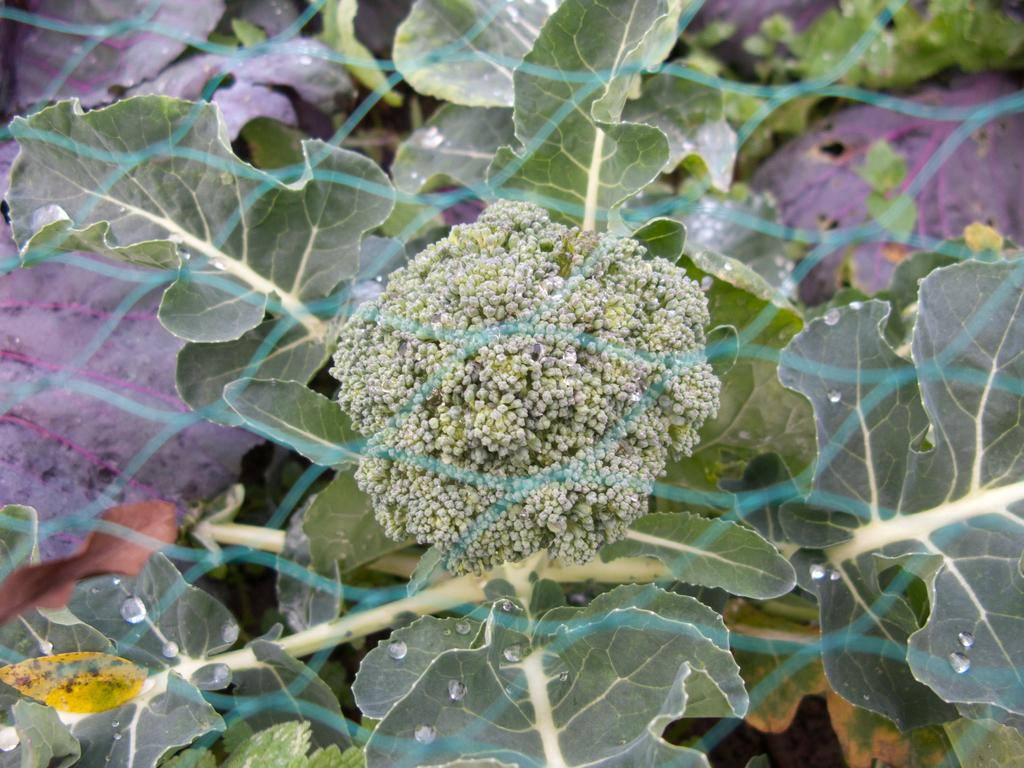What is located in the front of the image? There is a plant in the front of the image. What part of the plant is visible in the image? The plant has leaves on it. What is your opinion on the top doll in the image? There are no dolls present in the image, so it is not possible to answer a question about dolls. 